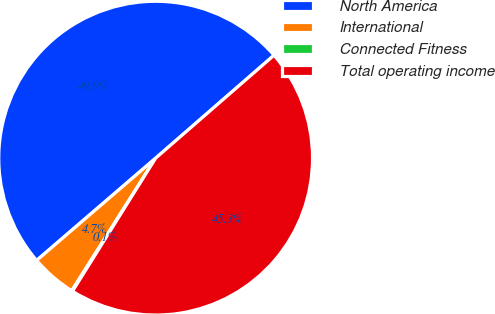<chart> <loc_0><loc_0><loc_500><loc_500><pie_chart><fcel>North America<fcel>International<fcel>Connected Fitness<fcel>Total operating income<nl><fcel>49.91%<fcel>4.72%<fcel>0.09%<fcel>45.28%<nl></chart> 